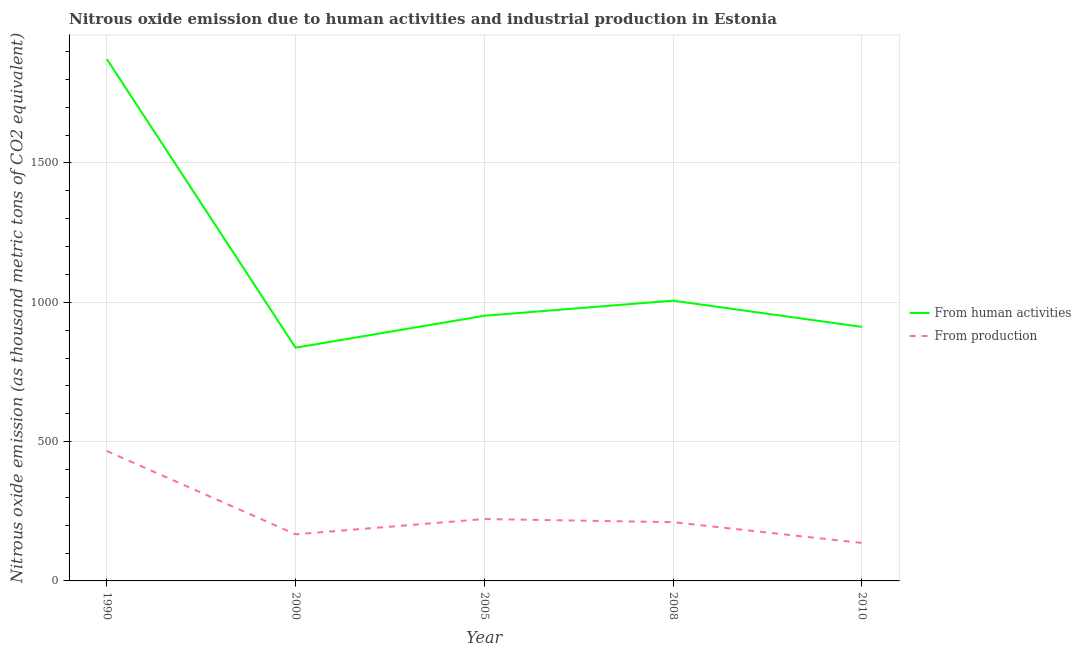How many different coloured lines are there?
Give a very brief answer. 2. What is the amount of emissions from human activities in 2008?
Your answer should be very brief. 1005.9. Across all years, what is the maximum amount of emissions generated from industries?
Give a very brief answer. 466.2. Across all years, what is the minimum amount of emissions from human activities?
Provide a short and direct response. 837. What is the total amount of emissions generated from industries in the graph?
Ensure brevity in your answer.  1202.8. What is the difference between the amount of emissions from human activities in 2000 and that in 2010?
Ensure brevity in your answer.  -74.7. What is the difference between the amount of emissions generated from industries in 2008 and the amount of emissions from human activities in 2010?
Keep it short and to the point. -700.8. What is the average amount of emissions generated from industries per year?
Provide a short and direct response. 240.56. In the year 2000, what is the difference between the amount of emissions from human activities and amount of emissions generated from industries?
Offer a terse response. 669.7. In how many years, is the amount of emissions from human activities greater than 1300 thousand metric tons?
Provide a short and direct response. 1. What is the ratio of the amount of emissions generated from industries in 2008 to that in 2010?
Ensure brevity in your answer.  1.55. Is the amount of emissions from human activities in 2000 less than that in 2010?
Offer a terse response. Yes. What is the difference between the highest and the second highest amount of emissions generated from industries?
Your answer should be compact. 244.1. What is the difference between the highest and the lowest amount of emissions from human activities?
Your answer should be very brief. 1035.9. How many lines are there?
Keep it short and to the point. 2. What is the difference between two consecutive major ticks on the Y-axis?
Give a very brief answer. 500. Does the graph contain any zero values?
Provide a succinct answer. No. Where does the legend appear in the graph?
Provide a succinct answer. Center right. How many legend labels are there?
Offer a terse response. 2. What is the title of the graph?
Make the answer very short. Nitrous oxide emission due to human activities and industrial production in Estonia. Does "RDB nonconcessional" appear as one of the legend labels in the graph?
Your response must be concise. No. What is the label or title of the X-axis?
Offer a very short reply. Year. What is the label or title of the Y-axis?
Keep it short and to the point. Nitrous oxide emission (as thousand metric tons of CO2 equivalent). What is the Nitrous oxide emission (as thousand metric tons of CO2 equivalent) of From human activities in 1990?
Make the answer very short. 1872.9. What is the Nitrous oxide emission (as thousand metric tons of CO2 equivalent) in From production in 1990?
Offer a terse response. 466.2. What is the Nitrous oxide emission (as thousand metric tons of CO2 equivalent) in From human activities in 2000?
Your answer should be compact. 837. What is the Nitrous oxide emission (as thousand metric tons of CO2 equivalent) in From production in 2000?
Ensure brevity in your answer.  167.3. What is the Nitrous oxide emission (as thousand metric tons of CO2 equivalent) in From human activities in 2005?
Give a very brief answer. 951.7. What is the Nitrous oxide emission (as thousand metric tons of CO2 equivalent) in From production in 2005?
Your response must be concise. 222.1. What is the Nitrous oxide emission (as thousand metric tons of CO2 equivalent) in From human activities in 2008?
Offer a very short reply. 1005.9. What is the Nitrous oxide emission (as thousand metric tons of CO2 equivalent) in From production in 2008?
Offer a terse response. 210.9. What is the Nitrous oxide emission (as thousand metric tons of CO2 equivalent) in From human activities in 2010?
Your answer should be very brief. 911.7. What is the Nitrous oxide emission (as thousand metric tons of CO2 equivalent) of From production in 2010?
Offer a very short reply. 136.3. Across all years, what is the maximum Nitrous oxide emission (as thousand metric tons of CO2 equivalent) of From human activities?
Your response must be concise. 1872.9. Across all years, what is the maximum Nitrous oxide emission (as thousand metric tons of CO2 equivalent) in From production?
Keep it short and to the point. 466.2. Across all years, what is the minimum Nitrous oxide emission (as thousand metric tons of CO2 equivalent) in From human activities?
Give a very brief answer. 837. Across all years, what is the minimum Nitrous oxide emission (as thousand metric tons of CO2 equivalent) in From production?
Make the answer very short. 136.3. What is the total Nitrous oxide emission (as thousand metric tons of CO2 equivalent) in From human activities in the graph?
Give a very brief answer. 5579.2. What is the total Nitrous oxide emission (as thousand metric tons of CO2 equivalent) in From production in the graph?
Make the answer very short. 1202.8. What is the difference between the Nitrous oxide emission (as thousand metric tons of CO2 equivalent) in From human activities in 1990 and that in 2000?
Give a very brief answer. 1035.9. What is the difference between the Nitrous oxide emission (as thousand metric tons of CO2 equivalent) of From production in 1990 and that in 2000?
Offer a very short reply. 298.9. What is the difference between the Nitrous oxide emission (as thousand metric tons of CO2 equivalent) in From human activities in 1990 and that in 2005?
Provide a succinct answer. 921.2. What is the difference between the Nitrous oxide emission (as thousand metric tons of CO2 equivalent) of From production in 1990 and that in 2005?
Give a very brief answer. 244.1. What is the difference between the Nitrous oxide emission (as thousand metric tons of CO2 equivalent) in From human activities in 1990 and that in 2008?
Your response must be concise. 867. What is the difference between the Nitrous oxide emission (as thousand metric tons of CO2 equivalent) in From production in 1990 and that in 2008?
Ensure brevity in your answer.  255.3. What is the difference between the Nitrous oxide emission (as thousand metric tons of CO2 equivalent) in From human activities in 1990 and that in 2010?
Offer a terse response. 961.2. What is the difference between the Nitrous oxide emission (as thousand metric tons of CO2 equivalent) of From production in 1990 and that in 2010?
Your answer should be very brief. 329.9. What is the difference between the Nitrous oxide emission (as thousand metric tons of CO2 equivalent) in From human activities in 2000 and that in 2005?
Make the answer very short. -114.7. What is the difference between the Nitrous oxide emission (as thousand metric tons of CO2 equivalent) in From production in 2000 and that in 2005?
Your response must be concise. -54.8. What is the difference between the Nitrous oxide emission (as thousand metric tons of CO2 equivalent) in From human activities in 2000 and that in 2008?
Your answer should be compact. -168.9. What is the difference between the Nitrous oxide emission (as thousand metric tons of CO2 equivalent) in From production in 2000 and that in 2008?
Your answer should be compact. -43.6. What is the difference between the Nitrous oxide emission (as thousand metric tons of CO2 equivalent) of From human activities in 2000 and that in 2010?
Your answer should be very brief. -74.7. What is the difference between the Nitrous oxide emission (as thousand metric tons of CO2 equivalent) of From human activities in 2005 and that in 2008?
Provide a short and direct response. -54.2. What is the difference between the Nitrous oxide emission (as thousand metric tons of CO2 equivalent) in From production in 2005 and that in 2008?
Offer a terse response. 11.2. What is the difference between the Nitrous oxide emission (as thousand metric tons of CO2 equivalent) in From production in 2005 and that in 2010?
Your answer should be very brief. 85.8. What is the difference between the Nitrous oxide emission (as thousand metric tons of CO2 equivalent) in From human activities in 2008 and that in 2010?
Offer a terse response. 94.2. What is the difference between the Nitrous oxide emission (as thousand metric tons of CO2 equivalent) in From production in 2008 and that in 2010?
Your answer should be compact. 74.6. What is the difference between the Nitrous oxide emission (as thousand metric tons of CO2 equivalent) of From human activities in 1990 and the Nitrous oxide emission (as thousand metric tons of CO2 equivalent) of From production in 2000?
Your response must be concise. 1705.6. What is the difference between the Nitrous oxide emission (as thousand metric tons of CO2 equivalent) in From human activities in 1990 and the Nitrous oxide emission (as thousand metric tons of CO2 equivalent) in From production in 2005?
Offer a very short reply. 1650.8. What is the difference between the Nitrous oxide emission (as thousand metric tons of CO2 equivalent) of From human activities in 1990 and the Nitrous oxide emission (as thousand metric tons of CO2 equivalent) of From production in 2008?
Make the answer very short. 1662. What is the difference between the Nitrous oxide emission (as thousand metric tons of CO2 equivalent) in From human activities in 1990 and the Nitrous oxide emission (as thousand metric tons of CO2 equivalent) in From production in 2010?
Provide a succinct answer. 1736.6. What is the difference between the Nitrous oxide emission (as thousand metric tons of CO2 equivalent) of From human activities in 2000 and the Nitrous oxide emission (as thousand metric tons of CO2 equivalent) of From production in 2005?
Keep it short and to the point. 614.9. What is the difference between the Nitrous oxide emission (as thousand metric tons of CO2 equivalent) in From human activities in 2000 and the Nitrous oxide emission (as thousand metric tons of CO2 equivalent) in From production in 2008?
Your answer should be very brief. 626.1. What is the difference between the Nitrous oxide emission (as thousand metric tons of CO2 equivalent) of From human activities in 2000 and the Nitrous oxide emission (as thousand metric tons of CO2 equivalent) of From production in 2010?
Your answer should be compact. 700.7. What is the difference between the Nitrous oxide emission (as thousand metric tons of CO2 equivalent) in From human activities in 2005 and the Nitrous oxide emission (as thousand metric tons of CO2 equivalent) in From production in 2008?
Your response must be concise. 740.8. What is the difference between the Nitrous oxide emission (as thousand metric tons of CO2 equivalent) in From human activities in 2005 and the Nitrous oxide emission (as thousand metric tons of CO2 equivalent) in From production in 2010?
Your answer should be compact. 815.4. What is the difference between the Nitrous oxide emission (as thousand metric tons of CO2 equivalent) in From human activities in 2008 and the Nitrous oxide emission (as thousand metric tons of CO2 equivalent) in From production in 2010?
Offer a very short reply. 869.6. What is the average Nitrous oxide emission (as thousand metric tons of CO2 equivalent) of From human activities per year?
Provide a short and direct response. 1115.84. What is the average Nitrous oxide emission (as thousand metric tons of CO2 equivalent) of From production per year?
Offer a terse response. 240.56. In the year 1990, what is the difference between the Nitrous oxide emission (as thousand metric tons of CO2 equivalent) in From human activities and Nitrous oxide emission (as thousand metric tons of CO2 equivalent) in From production?
Provide a succinct answer. 1406.7. In the year 2000, what is the difference between the Nitrous oxide emission (as thousand metric tons of CO2 equivalent) of From human activities and Nitrous oxide emission (as thousand metric tons of CO2 equivalent) of From production?
Your response must be concise. 669.7. In the year 2005, what is the difference between the Nitrous oxide emission (as thousand metric tons of CO2 equivalent) of From human activities and Nitrous oxide emission (as thousand metric tons of CO2 equivalent) of From production?
Your answer should be very brief. 729.6. In the year 2008, what is the difference between the Nitrous oxide emission (as thousand metric tons of CO2 equivalent) of From human activities and Nitrous oxide emission (as thousand metric tons of CO2 equivalent) of From production?
Provide a succinct answer. 795. In the year 2010, what is the difference between the Nitrous oxide emission (as thousand metric tons of CO2 equivalent) of From human activities and Nitrous oxide emission (as thousand metric tons of CO2 equivalent) of From production?
Your answer should be compact. 775.4. What is the ratio of the Nitrous oxide emission (as thousand metric tons of CO2 equivalent) of From human activities in 1990 to that in 2000?
Provide a succinct answer. 2.24. What is the ratio of the Nitrous oxide emission (as thousand metric tons of CO2 equivalent) in From production in 1990 to that in 2000?
Your answer should be compact. 2.79. What is the ratio of the Nitrous oxide emission (as thousand metric tons of CO2 equivalent) in From human activities in 1990 to that in 2005?
Make the answer very short. 1.97. What is the ratio of the Nitrous oxide emission (as thousand metric tons of CO2 equivalent) in From production in 1990 to that in 2005?
Make the answer very short. 2.1. What is the ratio of the Nitrous oxide emission (as thousand metric tons of CO2 equivalent) of From human activities in 1990 to that in 2008?
Give a very brief answer. 1.86. What is the ratio of the Nitrous oxide emission (as thousand metric tons of CO2 equivalent) of From production in 1990 to that in 2008?
Make the answer very short. 2.21. What is the ratio of the Nitrous oxide emission (as thousand metric tons of CO2 equivalent) of From human activities in 1990 to that in 2010?
Provide a short and direct response. 2.05. What is the ratio of the Nitrous oxide emission (as thousand metric tons of CO2 equivalent) in From production in 1990 to that in 2010?
Your answer should be very brief. 3.42. What is the ratio of the Nitrous oxide emission (as thousand metric tons of CO2 equivalent) of From human activities in 2000 to that in 2005?
Provide a succinct answer. 0.88. What is the ratio of the Nitrous oxide emission (as thousand metric tons of CO2 equivalent) in From production in 2000 to that in 2005?
Provide a succinct answer. 0.75. What is the ratio of the Nitrous oxide emission (as thousand metric tons of CO2 equivalent) in From human activities in 2000 to that in 2008?
Ensure brevity in your answer.  0.83. What is the ratio of the Nitrous oxide emission (as thousand metric tons of CO2 equivalent) in From production in 2000 to that in 2008?
Keep it short and to the point. 0.79. What is the ratio of the Nitrous oxide emission (as thousand metric tons of CO2 equivalent) of From human activities in 2000 to that in 2010?
Your answer should be compact. 0.92. What is the ratio of the Nitrous oxide emission (as thousand metric tons of CO2 equivalent) of From production in 2000 to that in 2010?
Your answer should be compact. 1.23. What is the ratio of the Nitrous oxide emission (as thousand metric tons of CO2 equivalent) in From human activities in 2005 to that in 2008?
Offer a terse response. 0.95. What is the ratio of the Nitrous oxide emission (as thousand metric tons of CO2 equivalent) in From production in 2005 to that in 2008?
Your answer should be compact. 1.05. What is the ratio of the Nitrous oxide emission (as thousand metric tons of CO2 equivalent) of From human activities in 2005 to that in 2010?
Provide a succinct answer. 1.04. What is the ratio of the Nitrous oxide emission (as thousand metric tons of CO2 equivalent) of From production in 2005 to that in 2010?
Make the answer very short. 1.63. What is the ratio of the Nitrous oxide emission (as thousand metric tons of CO2 equivalent) of From human activities in 2008 to that in 2010?
Ensure brevity in your answer.  1.1. What is the ratio of the Nitrous oxide emission (as thousand metric tons of CO2 equivalent) in From production in 2008 to that in 2010?
Make the answer very short. 1.55. What is the difference between the highest and the second highest Nitrous oxide emission (as thousand metric tons of CO2 equivalent) of From human activities?
Your answer should be very brief. 867. What is the difference between the highest and the second highest Nitrous oxide emission (as thousand metric tons of CO2 equivalent) in From production?
Your response must be concise. 244.1. What is the difference between the highest and the lowest Nitrous oxide emission (as thousand metric tons of CO2 equivalent) in From human activities?
Provide a short and direct response. 1035.9. What is the difference between the highest and the lowest Nitrous oxide emission (as thousand metric tons of CO2 equivalent) of From production?
Your answer should be very brief. 329.9. 